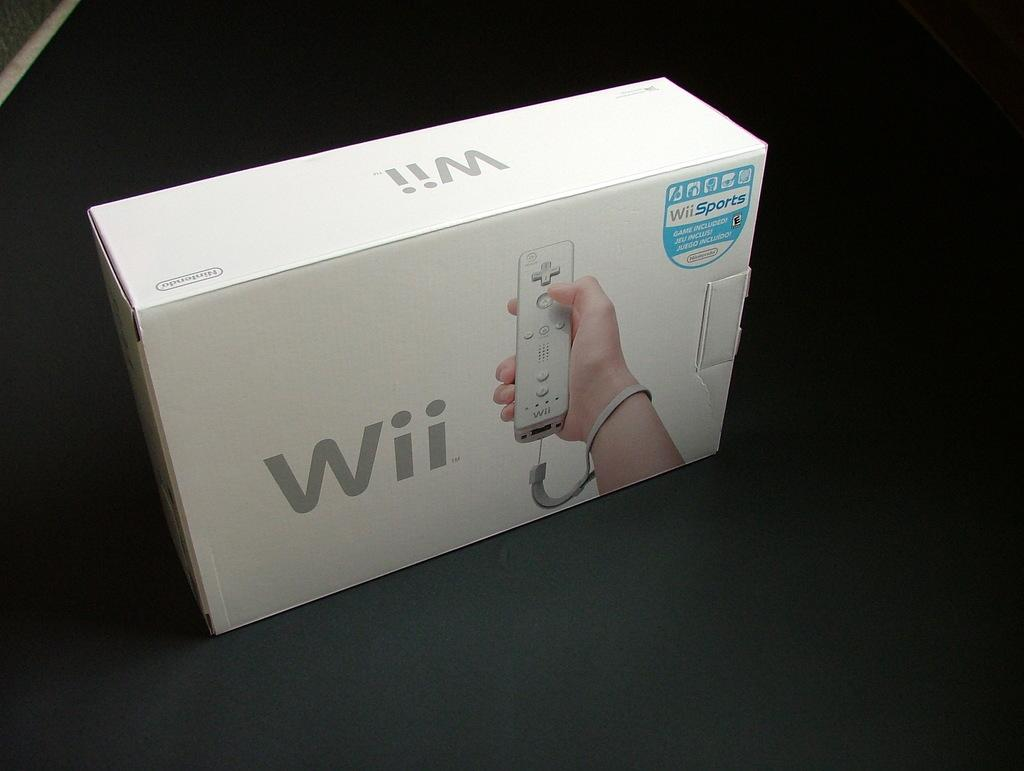<image>
Render a clear and concise summary of the photo. A retail box for the Nintendo Wii sitting on a black table. 